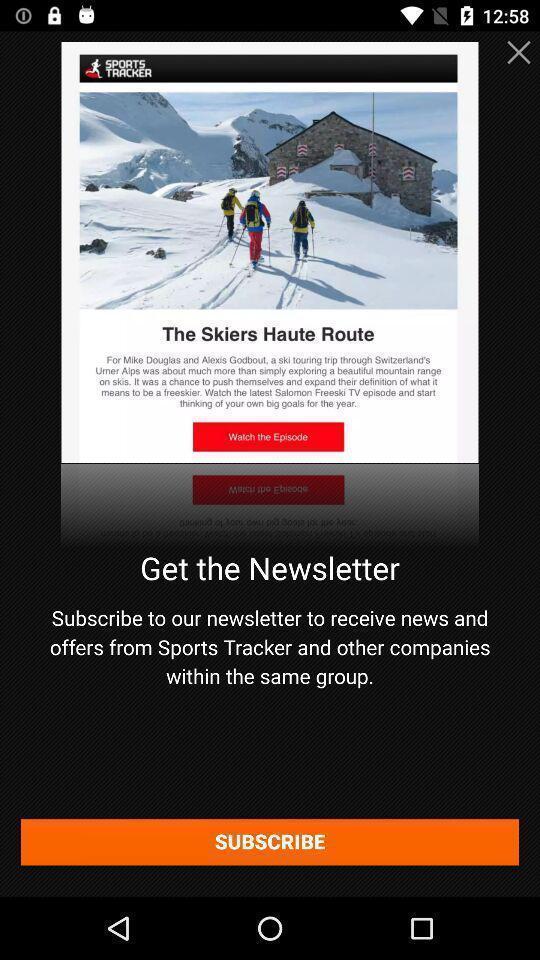Give me a summary of this screen capture. Window displaying a sports app. 